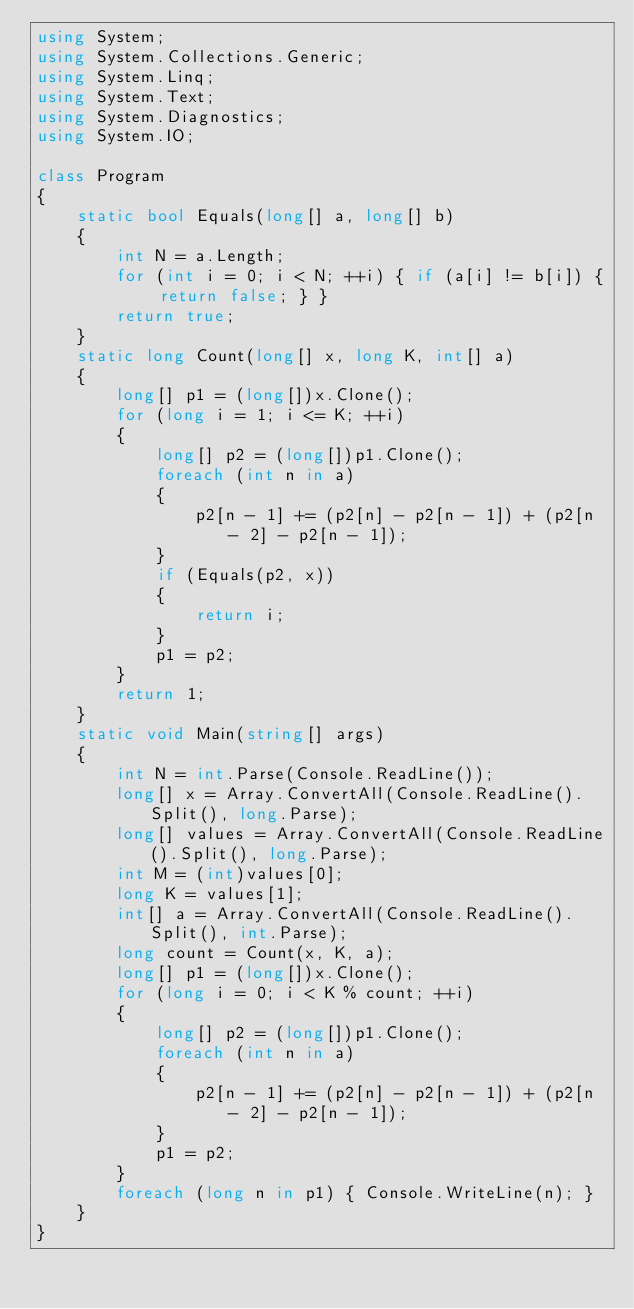Convert code to text. <code><loc_0><loc_0><loc_500><loc_500><_C#_>using System;
using System.Collections.Generic;
using System.Linq;
using System.Text;
using System.Diagnostics;
using System.IO;

class Program
{
    static bool Equals(long[] a, long[] b)
    {
        int N = a.Length;
        for (int i = 0; i < N; ++i) { if (a[i] != b[i]) { return false; } }
        return true;
    }
    static long Count(long[] x, long K, int[] a)
    {
        long[] p1 = (long[])x.Clone();
        for (long i = 1; i <= K; ++i)
        {
            long[] p2 = (long[])p1.Clone();
            foreach (int n in a)
            {
                p2[n - 1] += (p2[n] - p2[n - 1]) + (p2[n - 2] - p2[n - 1]);
            }
            if (Equals(p2, x))
            {
                return i;
            }
            p1 = p2;
        }
        return 1;
    }
    static void Main(string[] args)
    {
        int N = int.Parse(Console.ReadLine());
        long[] x = Array.ConvertAll(Console.ReadLine().Split(), long.Parse);
        long[] values = Array.ConvertAll(Console.ReadLine().Split(), long.Parse);
        int M = (int)values[0];
        long K = values[1];
        int[] a = Array.ConvertAll(Console.ReadLine().Split(), int.Parse);
        long count = Count(x, K, a);
        long[] p1 = (long[])x.Clone();
        for (long i = 0; i < K % count; ++i)
        {
            long[] p2 = (long[])p1.Clone();
            foreach (int n in a)
            {
                p2[n - 1] += (p2[n] - p2[n - 1]) + (p2[n - 2] - p2[n - 1]);
            }
            p1 = p2;
        }
        foreach (long n in p1) { Console.WriteLine(n); }
    }
}
</code> 